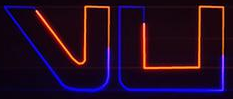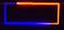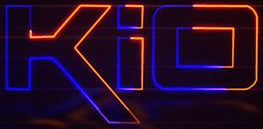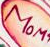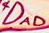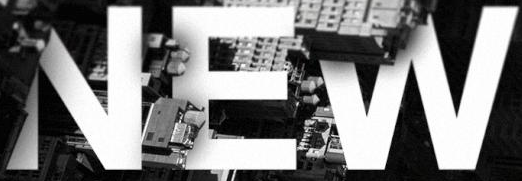Read the text content from these images in order, separated by a semicolon. vu; -; kio; MOM; DAD; NEW 